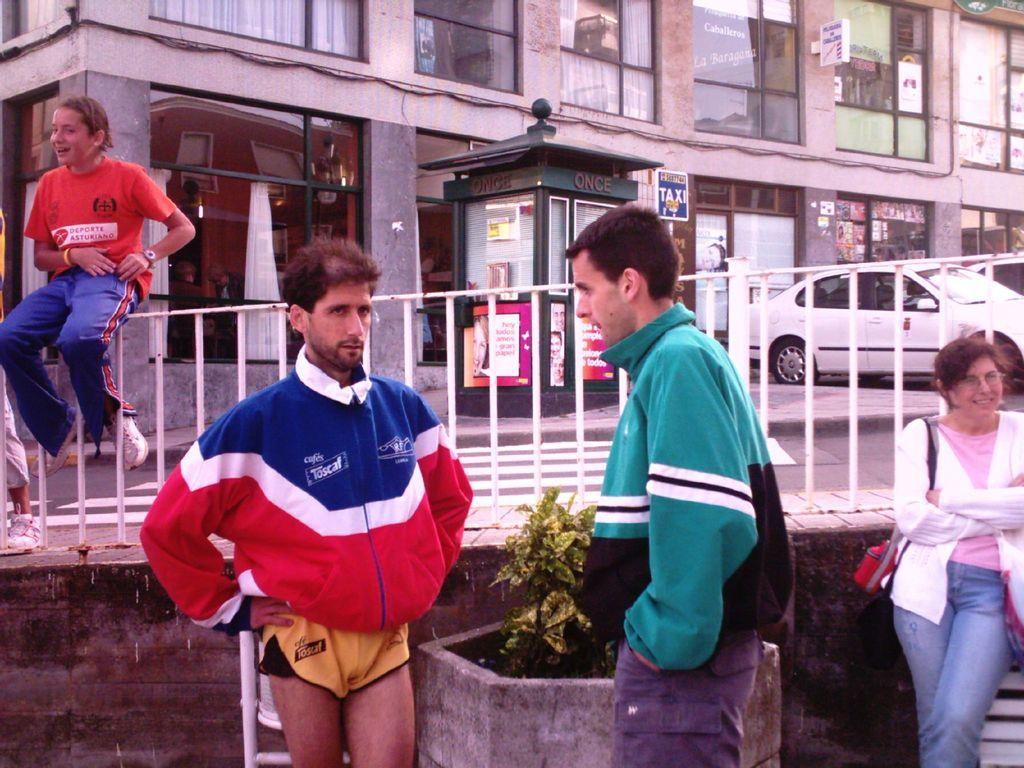<image>
Create a compact narrative representing the image presented. A person wearing an orange Deporte Asturiano shirt sits on a rail. 